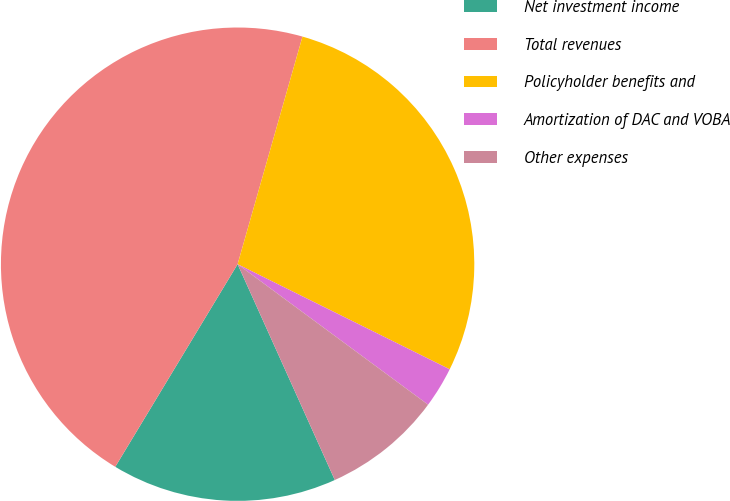Convert chart. <chart><loc_0><loc_0><loc_500><loc_500><pie_chart><fcel>Net investment income<fcel>Total revenues<fcel>Policyholder benefits and<fcel>Amortization of DAC and VOBA<fcel>Other expenses<nl><fcel>15.38%<fcel>45.77%<fcel>27.9%<fcel>2.79%<fcel>8.15%<nl></chart> 